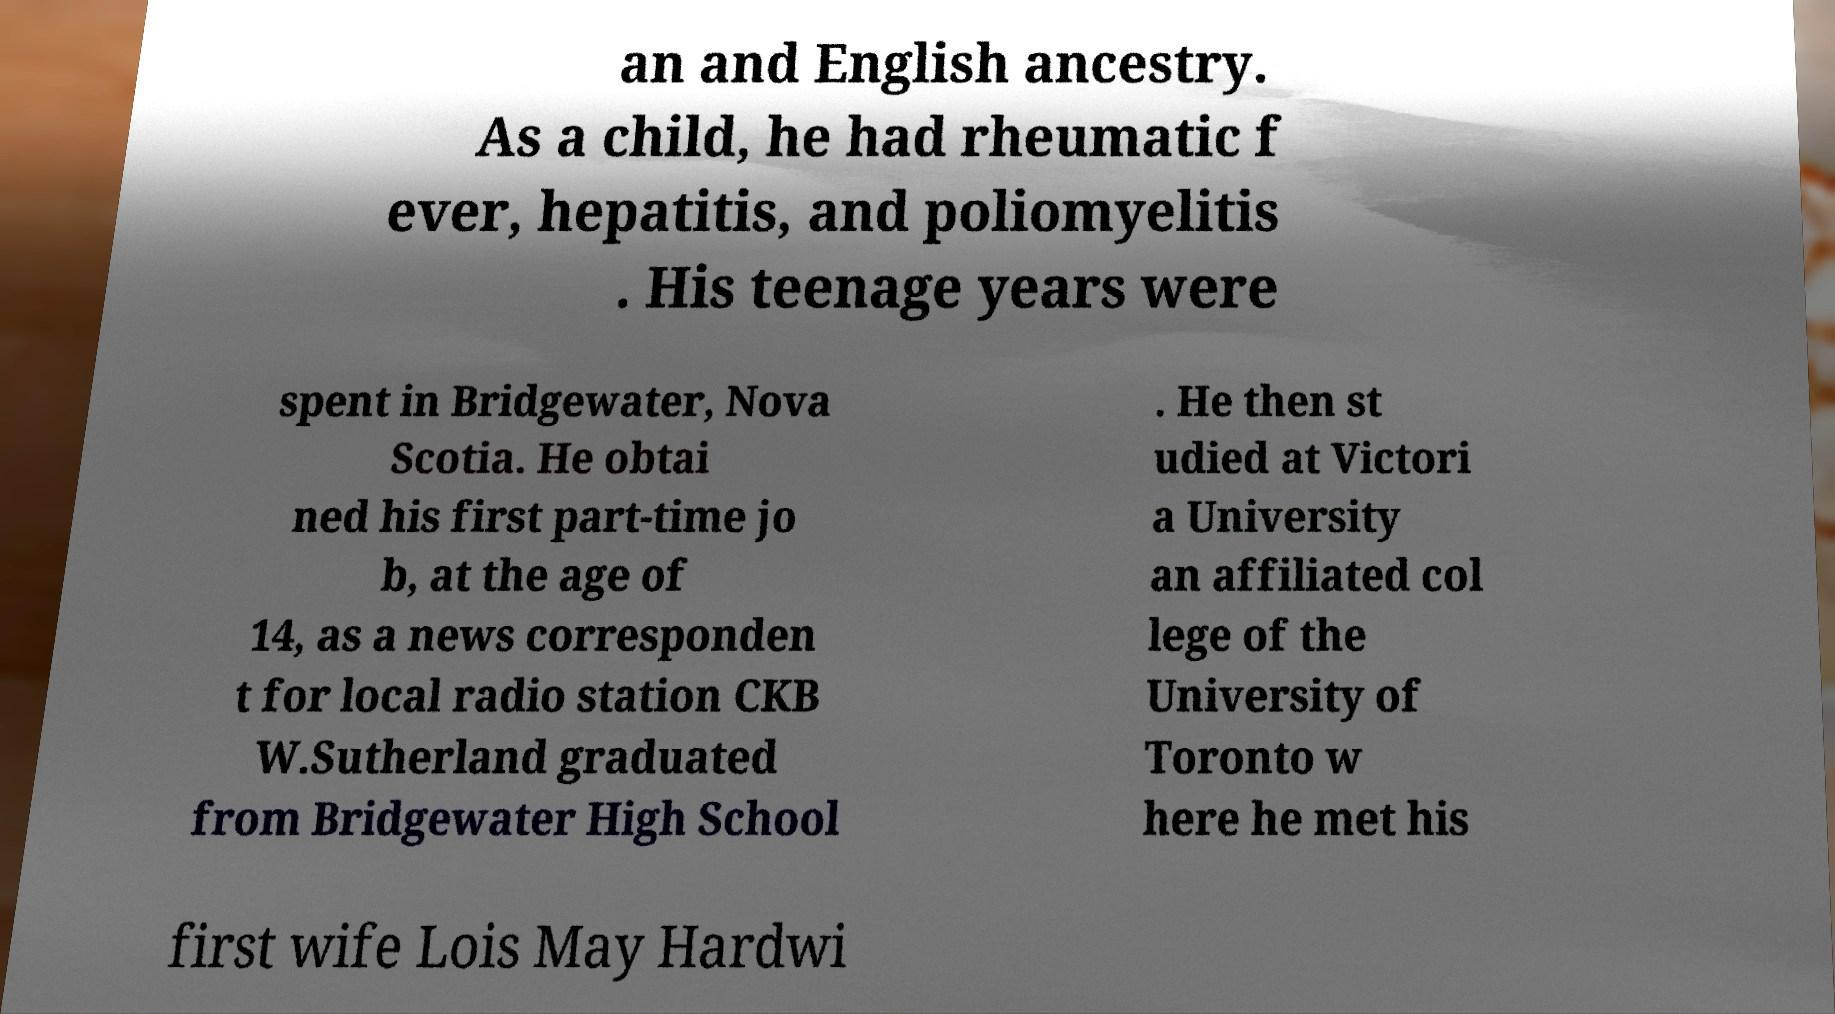I need the written content from this picture converted into text. Can you do that? an and English ancestry. As a child, he had rheumatic f ever, hepatitis, and poliomyelitis . His teenage years were spent in Bridgewater, Nova Scotia. He obtai ned his first part-time jo b, at the age of 14, as a news corresponden t for local radio station CKB W.Sutherland graduated from Bridgewater High School . He then st udied at Victori a University an affiliated col lege of the University of Toronto w here he met his first wife Lois May Hardwi 